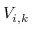<formula> <loc_0><loc_0><loc_500><loc_500>V _ { i , k }</formula> 